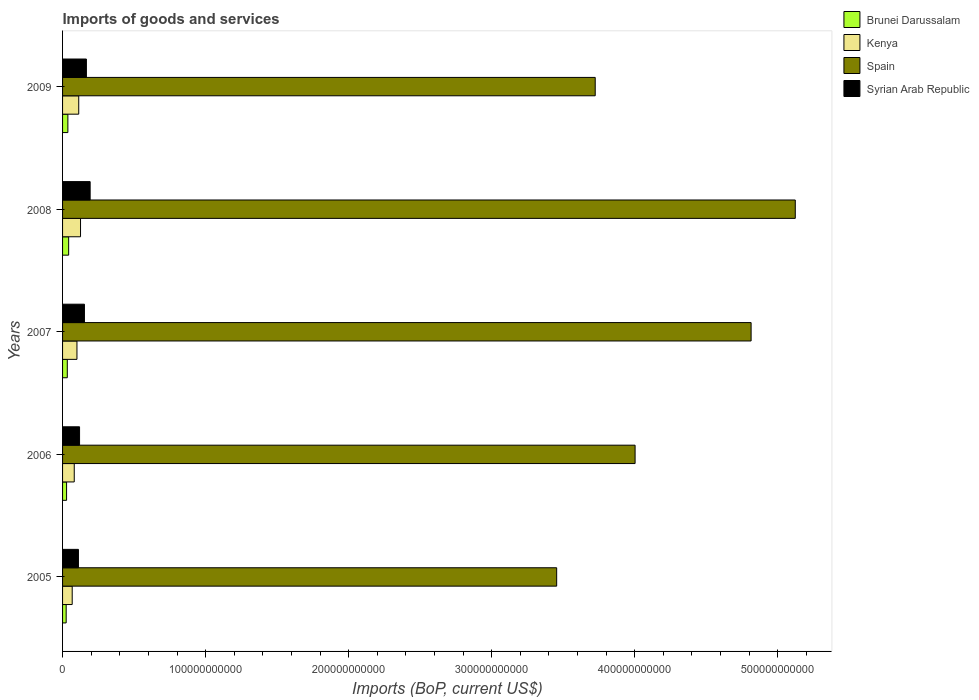How many groups of bars are there?
Provide a succinct answer. 5. Are the number of bars per tick equal to the number of legend labels?
Provide a succinct answer. Yes. How many bars are there on the 3rd tick from the bottom?
Keep it short and to the point. 4. What is the label of the 2nd group of bars from the top?
Make the answer very short. 2008. In how many cases, is the number of bars for a given year not equal to the number of legend labels?
Make the answer very short. 0. What is the amount spent on imports in Spain in 2006?
Offer a terse response. 4.00e+11. Across all years, what is the maximum amount spent on imports in Syrian Arab Republic?
Provide a short and direct response. 1.93e+1. Across all years, what is the minimum amount spent on imports in Syrian Arab Republic?
Make the answer very short. 1.11e+1. In which year was the amount spent on imports in Spain minimum?
Offer a very short reply. 2005. What is the total amount spent on imports in Kenya in the graph?
Provide a short and direct response. 4.88e+1. What is the difference between the amount spent on imports in Kenya in 2007 and that in 2008?
Keep it short and to the point. -2.50e+09. What is the difference between the amount spent on imports in Brunei Darussalam in 2005 and the amount spent on imports in Syrian Arab Republic in 2009?
Your response must be concise. -1.41e+1. What is the average amount spent on imports in Brunei Darussalam per year?
Your answer should be very brief. 3.32e+09. In the year 2005, what is the difference between the amount spent on imports in Brunei Darussalam and amount spent on imports in Spain?
Offer a very short reply. -3.43e+11. In how many years, is the amount spent on imports in Kenya greater than 380000000000 US$?
Offer a very short reply. 0. What is the ratio of the amount spent on imports in Spain in 2005 to that in 2008?
Your response must be concise. 0.67. Is the amount spent on imports in Kenya in 2005 less than that in 2009?
Your answer should be very brief. Yes. Is the difference between the amount spent on imports in Brunei Darussalam in 2007 and 2009 greater than the difference between the amount spent on imports in Spain in 2007 and 2009?
Provide a succinct answer. No. What is the difference between the highest and the second highest amount spent on imports in Brunei Darussalam?
Give a very brief answer. 5.44e+08. What is the difference between the highest and the lowest amount spent on imports in Spain?
Your answer should be very brief. 1.67e+11. In how many years, is the amount spent on imports in Syrian Arab Republic greater than the average amount spent on imports in Syrian Arab Republic taken over all years?
Your answer should be very brief. 3. Is it the case that in every year, the sum of the amount spent on imports in Brunei Darussalam and amount spent on imports in Spain is greater than the sum of amount spent on imports in Syrian Arab Republic and amount spent on imports in Kenya?
Your answer should be compact. No. What does the 3rd bar from the top in 2005 represents?
Keep it short and to the point. Kenya. Is it the case that in every year, the sum of the amount spent on imports in Brunei Darussalam and amount spent on imports in Spain is greater than the amount spent on imports in Syrian Arab Republic?
Give a very brief answer. Yes. How many bars are there?
Offer a terse response. 20. What is the difference between two consecutive major ticks on the X-axis?
Provide a succinct answer. 1.00e+11. Are the values on the major ticks of X-axis written in scientific E-notation?
Offer a very short reply. No. Does the graph contain any zero values?
Your answer should be compact. No. Where does the legend appear in the graph?
Provide a succinct answer. Top right. How are the legend labels stacked?
Make the answer very short. Vertical. What is the title of the graph?
Ensure brevity in your answer.  Imports of goods and services. Does "Qatar" appear as one of the legend labels in the graph?
Keep it short and to the point. No. What is the label or title of the X-axis?
Make the answer very short. Imports (BoP, current US$). What is the Imports (BoP, current US$) of Brunei Darussalam in 2005?
Your answer should be compact. 2.52e+09. What is the Imports (BoP, current US$) of Kenya in 2005?
Give a very brief answer. 6.74e+09. What is the Imports (BoP, current US$) of Spain in 2005?
Your answer should be compact. 3.45e+11. What is the Imports (BoP, current US$) in Syrian Arab Republic in 2005?
Ensure brevity in your answer.  1.11e+1. What is the Imports (BoP, current US$) in Brunei Darussalam in 2006?
Provide a succinct answer. 2.80e+09. What is the Imports (BoP, current US$) of Kenya in 2006?
Give a very brief answer. 8.17e+09. What is the Imports (BoP, current US$) in Spain in 2006?
Make the answer very short. 4.00e+11. What is the Imports (BoP, current US$) in Syrian Arab Republic in 2006?
Your response must be concise. 1.19e+1. What is the Imports (BoP, current US$) of Brunei Darussalam in 2007?
Provide a succinct answer. 3.31e+09. What is the Imports (BoP, current US$) in Kenya in 2007?
Your response must be concise. 1.01e+1. What is the Imports (BoP, current US$) in Spain in 2007?
Ensure brevity in your answer.  4.81e+11. What is the Imports (BoP, current US$) of Syrian Arab Republic in 2007?
Offer a terse response. 1.53e+1. What is the Imports (BoP, current US$) in Brunei Darussalam in 2008?
Provide a succinct answer. 4.26e+09. What is the Imports (BoP, current US$) of Kenya in 2008?
Ensure brevity in your answer.  1.26e+1. What is the Imports (BoP, current US$) of Spain in 2008?
Ensure brevity in your answer.  5.12e+11. What is the Imports (BoP, current US$) in Syrian Arab Republic in 2008?
Ensure brevity in your answer.  1.93e+1. What is the Imports (BoP, current US$) of Brunei Darussalam in 2009?
Your response must be concise. 3.72e+09. What is the Imports (BoP, current US$) of Kenya in 2009?
Offer a very short reply. 1.13e+1. What is the Imports (BoP, current US$) of Spain in 2009?
Your answer should be compact. 3.72e+11. What is the Imports (BoP, current US$) in Syrian Arab Republic in 2009?
Give a very brief answer. 1.67e+1. Across all years, what is the maximum Imports (BoP, current US$) of Brunei Darussalam?
Your answer should be compact. 4.26e+09. Across all years, what is the maximum Imports (BoP, current US$) in Kenya?
Ensure brevity in your answer.  1.26e+1. Across all years, what is the maximum Imports (BoP, current US$) of Spain?
Ensure brevity in your answer.  5.12e+11. Across all years, what is the maximum Imports (BoP, current US$) in Syrian Arab Republic?
Your response must be concise. 1.93e+1. Across all years, what is the minimum Imports (BoP, current US$) in Brunei Darussalam?
Keep it short and to the point. 2.52e+09. Across all years, what is the minimum Imports (BoP, current US$) of Kenya?
Your response must be concise. 6.74e+09. Across all years, what is the minimum Imports (BoP, current US$) in Spain?
Ensure brevity in your answer.  3.45e+11. Across all years, what is the minimum Imports (BoP, current US$) in Syrian Arab Republic?
Offer a terse response. 1.11e+1. What is the total Imports (BoP, current US$) in Brunei Darussalam in the graph?
Provide a short and direct response. 1.66e+1. What is the total Imports (BoP, current US$) in Kenya in the graph?
Give a very brief answer. 4.88e+1. What is the total Imports (BoP, current US$) in Spain in the graph?
Your response must be concise. 2.11e+12. What is the total Imports (BoP, current US$) of Syrian Arab Republic in the graph?
Your answer should be compact. 7.42e+1. What is the difference between the Imports (BoP, current US$) in Brunei Darussalam in 2005 and that in 2006?
Ensure brevity in your answer.  -2.80e+08. What is the difference between the Imports (BoP, current US$) in Kenya in 2005 and that in 2006?
Make the answer very short. -1.43e+09. What is the difference between the Imports (BoP, current US$) in Spain in 2005 and that in 2006?
Provide a succinct answer. -5.48e+1. What is the difference between the Imports (BoP, current US$) in Syrian Arab Republic in 2005 and that in 2006?
Your answer should be compact. -7.78e+08. What is the difference between the Imports (BoP, current US$) in Brunei Darussalam in 2005 and that in 2007?
Your answer should be compact. -7.87e+08. What is the difference between the Imports (BoP, current US$) in Kenya in 2005 and that in 2007?
Keep it short and to the point. -3.32e+09. What is the difference between the Imports (BoP, current US$) of Spain in 2005 and that in 2007?
Your answer should be very brief. -1.36e+11. What is the difference between the Imports (BoP, current US$) of Syrian Arab Republic in 2005 and that in 2007?
Your response must be concise. -4.19e+09. What is the difference between the Imports (BoP, current US$) of Brunei Darussalam in 2005 and that in 2008?
Offer a terse response. -1.74e+09. What is the difference between the Imports (BoP, current US$) in Kenya in 2005 and that in 2008?
Give a very brief answer. -5.82e+09. What is the difference between the Imports (BoP, current US$) in Spain in 2005 and that in 2008?
Your response must be concise. -1.67e+11. What is the difference between the Imports (BoP, current US$) of Syrian Arab Republic in 2005 and that in 2008?
Give a very brief answer. -8.18e+09. What is the difference between the Imports (BoP, current US$) in Brunei Darussalam in 2005 and that in 2009?
Provide a short and direct response. -1.19e+09. What is the difference between the Imports (BoP, current US$) of Kenya in 2005 and that in 2009?
Offer a very short reply. -4.56e+09. What is the difference between the Imports (BoP, current US$) of Spain in 2005 and that in 2009?
Offer a very short reply. -2.69e+1. What is the difference between the Imports (BoP, current US$) in Syrian Arab Republic in 2005 and that in 2009?
Offer a terse response. -5.57e+09. What is the difference between the Imports (BoP, current US$) in Brunei Darussalam in 2006 and that in 2007?
Give a very brief answer. -5.07e+08. What is the difference between the Imports (BoP, current US$) in Kenya in 2006 and that in 2007?
Provide a short and direct response. -1.89e+09. What is the difference between the Imports (BoP, current US$) of Spain in 2006 and that in 2007?
Offer a very short reply. -8.11e+1. What is the difference between the Imports (BoP, current US$) of Syrian Arab Republic in 2006 and that in 2007?
Your answer should be very brief. -3.41e+09. What is the difference between the Imports (BoP, current US$) in Brunei Darussalam in 2006 and that in 2008?
Provide a succinct answer. -1.46e+09. What is the difference between the Imports (BoP, current US$) in Kenya in 2006 and that in 2008?
Your answer should be compact. -4.39e+09. What is the difference between the Imports (BoP, current US$) of Spain in 2006 and that in 2008?
Provide a succinct answer. -1.12e+11. What is the difference between the Imports (BoP, current US$) of Syrian Arab Republic in 2006 and that in 2008?
Ensure brevity in your answer.  -7.40e+09. What is the difference between the Imports (BoP, current US$) in Brunei Darussalam in 2006 and that in 2009?
Your answer should be compact. -9.15e+08. What is the difference between the Imports (BoP, current US$) in Kenya in 2006 and that in 2009?
Your answer should be compact. -3.13e+09. What is the difference between the Imports (BoP, current US$) in Spain in 2006 and that in 2009?
Provide a succinct answer. 2.79e+1. What is the difference between the Imports (BoP, current US$) in Syrian Arab Republic in 2006 and that in 2009?
Offer a very short reply. -4.79e+09. What is the difference between the Imports (BoP, current US$) of Brunei Darussalam in 2007 and that in 2008?
Provide a short and direct response. -9.52e+08. What is the difference between the Imports (BoP, current US$) of Kenya in 2007 and that in 2008?
Ensure brevity in your answer.  -2.50e+09. What is the difference between the Imports (BoP, current US$) of Spain in 2007 and that in 2008?
Ensure brevity in your answer.  -3.09e+1. What is the difference between the Imports (BoP, current US$) in Syrian Arab Republic in 2007 and that in 2008?
Your answer should be compact. -3.99e+09. What is the difference between the Imports (BoP, current US$) in Brunei Darussalam in 2007 and that in 2009?
Offer a terse response. -4.08e+08. What is the difference between the Imports (BoP, current US$) of Kenya in 2007 and that in 2009?
Keep it short and to the point. -1.24e+09. What is the difference between the Imports (BoP, current US$) of Spain in 2007 and that in 2009?
Provide a succinct answer. 1.09e+11. What is the difference between the Imports (BoP, current US$) of Syrian Arab Republic in 2007 and that in 2009?
Make the answer very short. -1.38e+09. What is the difference between the Imports (BoP, current US$) of Brunei Darussalam in 2008 and that in 2009?
Make the answer very short. 5.44e+08. What is the difference between the Imports (BoP, current US$) of Kenya in 2008 and that in 2009?
Offer a very short reply. 1.26e+09. What is the difference between the Imports (BoP, current US$) of Spain in 2008 and that in 2009?
Your answer should be compact. 1.40e+11. What is the difference between the Imports (BoP, current US$) of Syrian Arab Republic in 2008 and that in 2009?
Provide a succinct answer. 2.61e+09. What is the difference between the Imports (BoP, current US$) of Brunei Darussalam in 2005 and the Imports (BoP, current US$) of Kenya in 2006?
Your response must be concise. -5.65e+09. What is the difference between the Imports (BoP, current US$) of Brunei Darussalam in 2005 and the Imports (BoP, current US$) of Spain in 2006?
Keep it short and to the point. -3.98e+11. What is the difference between the Imports (BoP, current US$) of Brunei Darussalam in 2005 and the Imports (BoP, current US$) of Syrian Arab Republic in 2006?
Provide a short and direct response. -9.36e+09. What is the difference between the Imports (BoP, current US$) in Kenya in 2005 and the Imports (BoP, current US$) in Spain in 2006?
Make the answer very short. -3.94e+11. What is the difference between the Imports (BoP, current US$) in Kenya in 2005 and the Imports (BoP, current US$) in Syrian Arab Republic in 2006?
Offer a very short reply. -5.14e+09. What is the difference between the Imports (BoP, current US$) in Spain in 2005 and the Imports (BoP, current US$) in Syrian Arab Republic in 2006?
Ensure brevity in your answer.  3.34e+11. What is the difference between the Imports (BoP, current US$) of Brunei Darussalam in 2005 and the Imports (BoP, current US$) of Kenya in 2007?
Your answer should be compact. -7.54e+09. What is the difference between the Imports (BoP, current US$) of Brunei Darussalam in 2005 and the Imports (BoP, current US$) of Spain in 2007?
Make the answer very short. -4.79e+11. What is the difference between the Imports (BoP, current US$) of Brunei Darussalam in 2005 and the Imports (BoP, current US$) of Syrian Arab Republic in 2007?
Provide a succinct answer. -1.28e+1. What is the difference between the Imports (BoP, current US$) in Kenya in 2005 and the Imports (BoP, current US$) in Spain in 2007?
Ensure brevity in your answer.  -4.75e+11. What is the difference between the Imports (BoP, current US$) in Kenya in 2005 and the Imports (BoP, current US$) in Syrian Arab Republic in 2007?
Your answer should be very brief. -8.55e+09. What is the difference between the Imports (BoP, current US$) in Spain in 2005 and the Imports (BoP, current US$) in Syrian Arab Republic in 2007?
Offer a very short reply. 3.30e+11. What is the difference between the Imports (BoP, current US$) in Brunei Darussalam in 2005 and the Imports (BoP, current US$) in Kenya in 2008?
Provide a short and direct response. -1.00e+1. What is the difference between the Imports (BoP, current US$) of Brunei Darussalam in 2005 and the Imports (BoP, current US$) of Spain in 2008?
Ensure brevity in your answer.  -5.10e+11. What is the difference between the Imports (BoP, current US$) in Brunei Darussalam in 2005 and the Imports (BoP, current US$) in Syrian Arab Republic in 2008?
Make the answer very short. -1.68e+1. What is the difference between the Imports (BoP, current US$) in Kenya in 2005 and the Imports (BoP, current US$) in Spain in 2008?
Your answer should be compact. -5.06e+11. What is the difference between the Imports (BoP, current US$) of Kenya in 2005 and the Imports (BoP, current US$) of Syrian Arab Republic in 2008?
Provide a succinct answer. -1.25e+1. What is the difference between the Imports (BoP, current US$) in Spain in 2005 and the Imports (BoP, current US$) in Syrian Arab Republic in 2008?
Provide a succinct answer. 3.26e+11. What is the difference between the Imports (BoP, current US$) in Brunei Darussalam in 2005 and the Imports (BoP, current US$) in Kenya in 2009?
Your answer should be very brief. -8.78e+09. What is the difference between the Imports (BoP, current US$) in Brunei Darussalam in 2005 and the Imports (BoP, current US$) in Spain in 2009?
Your response must be concise. -3.70e+11. What is the difference between the Imports (BoP, current US$) of Brunei Darussalam in 2005 and the Imports (BoP, current US$) of Syrian Arab Republic in 2009?
Your answer should be compact. -1.41e+1. What is the difference between the Imports (BoP, current US$) in Kenya in 2005 and the Imports (BoP, current US$) in Spain in 2009?
Keep it short and to the point. -3.66e+11. What is the difference between the Imports (BoP, current US$) of Kenya in 2005 and the Imports (BoP, current US$) of Syrian Arab Republic in 2009?
Make the answer very short. -9.93e+09. What is the difference between the Imports (BoP, current US$) in Spain in 2005 and the Imports (BoP, current US$) in Syrian Arab Republic in 2009?
Keep it short and to the point. 3.29e+11. What is the difference between the Imports (BoP, current US$) in Brunei Darussalam in 2006 and the Imports (BoP, current US$) in Kenya in 2007?
Offer a very short reply. -7.26e+09. What is the difference between the Imports (BoP, current US$) in Brunei Darussalam in 2006 and the Imports (BoP, current US$) in Spain in 2007?
Provide a short and direct response. -4.79e+11. What is the difference between the Imports (BoP, current US$) of Brunei Darussalam in 2006 and the Imports (BoP, current US$) of Syrian Arab Republic in 2007?
Give a very brief answer. -1.25e+1. What is the difference between the Imports (BoP, current US$) of Kenya in 2006 and the Imports (BoP, current US$) of Spain in 2007?
Provide a short and direct response. -4.73e+11. What is the difference between the Imports (BoP, current US$) of Kenya in 2006 and the Imports (BoP, current US$) of Syrian Arab Republic in 2007?
Offer a terse response. -7.12e+09. What is the difference between the Imports (BoP, current US$) in Spain in 2006 and the Imports (BoP, current US$) in Syrian Arab Republic in 2007?
Offer a terse response. 3.85e+11. What is the difference between the Imports (BoP, current US$) in Brunei Darussalam in 2006 and the Imports (BoP, current US$) in Kenya in 2008?
Ensure brevity in your answer.  -9.76e+09. What is the difference between the Imports (BoP, current US$) of Brunei Darussalam in 2006 and the Imports (BoP, current US$) of Spain in 2008?
Your answer should be very brief. -5.09e+11. What is the difference between the Imports (BoP, current US$) in Brunei Darussalam in 2006 and the Imports (BoP, current US$) in Syrian Arab Republic in 2008?
Keep it short and to the point. -1.65e+1. What is the difference between the Imports (BoP, current US$) in Kenya in 2006 and the Imports (BoP, current US$) in Spain in 2008?
Offer a very short reply. -5.04e+11. What is the difference between the Imports (BoP, current US$) in Kenya in 2006 and the Imports (BoP, current US$) in Syrian Arab Republic in 2008?
Offer a terse response. -1.11e+1. What is the difference between the Imports (BoP, current US$) in Spain in 2006 and the Imports (BoP, current US$) in Syrian Arab Republic in 2008?
Make the answer very short. 3.81e+11. What is the difference between the Imports (BoP, current US$) in Brunei Darussalam in 2006 and the Imports (BoP, current US$) in Kenya in 2009?
Give a very brief answer. -8.50e+09. What is the difference between the Imports (BoP, current US$) of Brunei Darussalam in 2006 and the Imports (BoP, current US$) of Spain in 2009?
Your response must be concise. -3.70e+11. What is the difference between the Imports (BoP, current US$) of Brunei Darussalam in 2006 and the Imports (BoP, current US$) of Syrian Arab Republic in 2009?
Offer a very short reply. -1.39e+1. What is the difference between the Imports (BoP, current US$) of Kenya in 2006 and the Imports (BoP, current US$) of Spain in 2009?
Give a very brief answer. -3.64e+11. What is the difference between the Imports (BoP, current US$) of Kenya in 2006 and the Imports (BoP, current US$) of Syrian Arab Republic in 2009?
Keep it short and to the point. -8.50e+09. What is the difference between the Imports (BoP, current US$) in Spain in 2006 and the Imports (BoP, current US$) in Syrian Arab Republic in 2009?
Ensure brevity in your answer.  3.84e+11. What is the difference between the Imports (BoP, current US$) of Brunei Darussalam in 2007 and the Imports (BoP, current US$) of Kenya in 2008?
Offer a terse response. -9.25e+09. What is the difference between the Imports (BoP, current US$) in Brunei Darussalam in 2007 and the Imports (BoP, current US$) in Spain in 2008?
Provide a short and direct response. -5.09e+11. What is the difference between the Imports (BoP, current US$) in Brunei Darussalam in 2007 and the Imports (BoP, current US$) in Syrian Arab Republic in 2008?
Ensure brevity in your answer.  -1.60e+1. What is the difference between the Imports (BoP, current US$) in Kenya in 2007 and the Imports (BoP, current US$) in Spain in 2008?
Offer a very short reply. -5.02e+11. What is the difference between the Imports (BoP, current US$) in Kenya in 2007 and the Imports (BoP, current US$) in Syrian Arab Republic in 2008?
Offer a terse response. -9.22e+09. What is the difference between the Imports (BoP, current US$) in Spain in 2007 and the Imports (BoP, current US$) in Syrian Arab Republic in 2008?
Provide a succinct answer. 4.62e+11. What is the difference between the Imports (BoP, current US$) of Brunei Darussalam in 2007 and the Imports (BoP, current US$) of Kenya in 2009?
Keep it short and to the point. -7.99e+09. What is the difference between the Imports (BoP, current US$) in Brunei Darussalam in 2007 and the Imports (BoP, current US$) in Spain in 2009?
Provide a succinct answer. -3.69e+11. What is the difference between the Imports (BoP, current US$) in Brunei Darussalam in 2007 and the Imports (BoP, current US$) in Syrian Arab Republic in 2009?
Make the answer very short. -1.34e+1. What is the difference between the Imports (BoP, current US$) of Kenya in 2007 and the Imports (BoP, current US$) of Spain in 2009?
Offer a terse response. -3.62e+11. What is the difference between the Imports (BoP, current US$) in Kenya in 2007 and the Imports (BoP, current US$) in Syrian Arab Republic in 2009?
Ensure brevity in your answer.  -6.61e+09. What is the difference between the Imports (BoP, current US$) in Spain in 2007 and the Imports (BoP, current US$) in Syrian Arab Republic in 2009?
Make the answer very short. 4.65e+11. What is the difference between the Imports (BoP, current US$) in Brunei Darussalam in 2008 and the Imports (BoP, current US$) in Kenya in 2009?
Offer a terse response. -7.04e+09. What is the difference between the Imports (BoP, current US$) of Brunei Darussalam in 2008 and the Imports (BoP, current US$) of Spain in 2009?
Ensure brevity in your answer.  -3.68e+11. What is the difference between the Imports (BoP, current US$) in Brunei Darussalam in 2008 and the Imports (BoP, current US$) in Syrian Arab Republic in 2009?
Offer a terse response. -1.24e+1. What is the difference between the Imports (BoP, current US$) of Kenya in 2008 and the Imports (BoP, current US$) of Spain in 2009?
Offer a very short reply. -3.60e+11. What is the difference between the Imports (BoP, current US$) of Kenya in 2008 and the Imports (BoP, current US$) of Syrian Arab Republic in 2009?
Offer a very short reply. -4.11e+09. What is the difference between the Imports (BoP, current US$) of Spain in 2008 and the Imports (BoP, current US$) of Syrian Arab Republic in 2009?
Your response must be concise. 4.96e+11. What is the average Imports (BoP, current US$) of Brunei Darussalam per year?
Ensure brevity in your answer.  3.32e+09. What is the average Imports (BoP, current US$) of Kenya per year?
Provide a succinct answer. 9.77e+09. What is the average Imports (BoP, current US$) of Spain per year?
Your answer should be very brief. 4.22e+11. What is the average Imports (BoP, current US$) of Syrian Arab Republic per year?
Your response must be concise. 1.48e+1. In the year 2005, what is the difference between the Imports (BoP, current US$) in Brunei Darussalam and Imports (BoP, current US$) in Kenya?
Provide a succinct answer. -4.22e+09. In the year 2005, what is the difference between the Imports (BoP, current US$) of Brunei Darussalam and Imports (BoP, current US$) of Spain?
Your answer should be compact. -3.43e+11. In the year 2005, what is the difference between the Imports (BoP, current US$) in Brunei Darussalam and Imports (BoP, current US$) in Syrian Arab Republic?
Keep it short and to the point. -8.58e+09. In the year 2005, what is the difference between the Imports (BoP, current US$) in Kenya and Imports (BoP, current US$) in Spain?
Provide a short and direct response. -3.39e+11. In the year 2005, what is the difference between the Imports (BoP, current US$) in Kenya and Imports (BoP, current US$) in Syrian Arab Republic?
Offer a very short reply. -4.36e+09. In the year 2005, what is the difference between the Imports (BoP, current US$) of Spain and Imports (BoP, current US$) of Syrian Arab Republic?
Your answer should be very brief. 3.34e+11. In the year 2006, what is the difference between the Imports (BoP, current US$) in Brunei Darussalam and Imports (BoP, current US$) in Kenya?
Make the answer very short. -5.37e+09. In the year 2006, what is the difference between the Imports (BoP, current US$) of Brunei Darussalam and Imports (BoP, current US$) of Spain?
Your answer should be compact. -3.97e+11. In the year 2006, what is the difference between the Imports (BoP, current US$) of Brunei Darussalam and Imports (BoP, current US$) of Syrian Arab Republic?
Give a very brief answer. -9.08e+09. In the year 2006, what is the difference between the Imports (BoP, current US$) in Kenya and Imports (BoP, current US$) in Spain?
Offer a terse response. -3.92e+11. In the year 2006, what is the difference between the Imports (BoP, current US$) of Kenya and Imports (BoP, current US$) of Syrian Arab Republic?
Offer a terse response. -3.71e+09. In the year 2006, what is the difference between the Imports (BoP, current US$) of Spain and Imports (BoP, current US$) of Syrian Arab Republic?
Your answer should be compact. 3.88e+11. In the year 2007, what is the difference between the Imports (BoP, current US$) of Brunei Darussalam and Imports (BoP, current US$) of Kenya?
Your answer should be very brief. -6.75e+09. In the year 2007, what is the difference between the Imports (BoP, current US$) in Brunei Darussalam and Imports (BoP, current US$) in Spain?
Provide a short and direct response. -4.78e+11. In the year 2007, what is the difference between the Imports (BoP, current US$) of Brunei Darussalam and Imports (BoP, current US$) of Syrian Arab Republic?
Offer a very short reply. -1.20e+1. In the year 2007, what is the difference between the Imports (BoP, current US$) in Kenya and Imports (BoP, current US$) in Spain?
Your answer should be very brief. -4.71e+11. In the year 2007, what is the difference between the Imports (BoP, current US$) in Kenya and Imports (BoP, current US$) in Syrian Arab Republic?
Your answer should be very brief. -5.23e+09. In the year 2007, what is the difference between the Imports (BoP, current US$) of Spain and Imports (BoP, current US$) of Syrian Arab Republic?
Provide a succinct answer. 4.66e+11. In the year 2008, what is the difference between the Imports (BoP, current US$) of Brunei Darussalam and Imports (BoP, current US$) of Kenya?
Provide a short and direct response. -8.30e+09. In the year 2008, what is the difference between the Imports (BoP, current US$) of Brunei Darussalam and Imports (BoP, current US$) of Spain?
Your response must be concise. -5.08e+11. In the year 2008, what is the difference between the Imports (BoP, current US$) in Brunei Darussalam and Imports (BoP, current US$) in Syrian Arab Republic?
Make the answer very short. -1.50e+1. In the year 2008, what is the difference between the Imports (BoP, current US$) in Kenya and Imports (BoP, current US$) in Spain?
Offer a very short reply. -5.00e+11. In the year 2008, what is the difference between the Imports (BoP, current US$) of Kenya and Imports (BoP, current US$) of Syrian Arab Republic?
Your answer should be compact. -6.72e+09. In the year 2008, what is the difference between the Imports (BoP, current US$) of Spain and Imports (BoP, current US$) of Syrian Arab Republic?
Provide a succinct answer. 4.93e+11. In the year 2009, what is the difference between the Imports (BoP, current US$) of Brunei Darussalam and Imports (BoP, current US$) of Kenya?
Provide a succinct answer. -7.59e+09. In the year 2009, what is the difference between the Imports (BoP, current US$) of Brunei Darussalam and Imports (BoP, current US$) of Spain?
Your answer should be very brief. -3.69e+11. In the year 2009, what is the difference between the Imports (BoP, current US$) of Brunei Darussalam and Imports (BoP, current US$) of Syrian Arab Republic?
Offer a very short reply. -1.30e+1. In the year 2009, what is the difference between the Imports (BoP, current US$) in Kenya and Imports (BoP, current US$) in Spain?
Your response must be concise. -3.61e+11. In the year 2009, what is the difference between the Imports (BoP, current US$) in Kenya and Imports (BoP, current US$) in Syrian Arab Republic?
Make the answer very short. -5.37e+09. In the year 2009, what is the difference between the Imports (BoP, current US$) in Spain and Imports (BoP, current US$) in Syrian Arab Republic?
Offer a terse response. 3.56e+11. What is the ratio of the Imports (BoP, current US$) in Brunei Darussalam in 2005 to that in 2006?
Ensure brevity in your answer.  0.9. What is the ratio of the Imports (BoP, current US$) of Kenya in 2005 to that in 2006?
Your response must be concise. 0.82. What is the ratio of the Imports (BoP, current US$) in Spain in 2005 to that in 2006?
Make the answer very short. 0.86. What is the ratio of the Imports (BoP, current US$) in Syrian Arab Republic in 2005 to that in 2006?
Provide a short and direct response. 0.93. What is the ratio of the Imports (BoP, current US$) in Brunei Darussalam in 2005 to that in 2007?
Your answer should be compact. 0.76. What is the ratio of the Imports (BoP, current US$) in Kenya in 2005 to that in 2007?
Offer a very short reply. 0.67. What is the ratio of the Imports (BoP, current US$) in Spain in 2005 to that in 2007?
Keep it short and to the point. 0.72. What is the ratio of the Imports (BoP, current US$) of Syrian Arab Republic in 2005 to that in 2007?
Give a very brief answer. 0.73. What is the ratio of the Imports (BoP, current US$) in Brunei Darussalam in 2005 to that in 2008?
Keep it short and to the point. 0.59. What is the ratio of the Imports (BoP, current US$) of Kenya in 2005 to that in 2008?
Keep it short and to the point. 0.54. What is the ratio of the Imports (BoP, current US$) of Spain in 2005 to that in 2008?
Give a very brief answer. 0.67. What is the ratio of the Imports (BoP, current US$) of Syrian Arab Republic in 2005 to that in 2008?
Your answer should be very brief. 0.58. What is the ratio of the Imports (BoP, current US$) in Brunei Darussalam in 2005 to that in 2009?
Your answer should be compact. 0.68. What is the ratio of the Imports (BoP, current US$) of Kenya in 2005 to that in 2009?
Keep it short and to the point. 0.6. What is the ratio of the Imports (BoP, current US$) of Spain in 2005 to that in 2009?
Keep it short and to the point. 0.93. What is the ratio of the Imports (BoP, current US$) of Syrian Arab Republic in 2005 to that in 2009?
Provide a succinct answer. 0.67. What is the ratio of the Imports (BoP, current US$) in Brunei Darussalam in 2006 to that in 2007?
Provide a succinct answer. 0.85. What is the ratio of the Imports (BoP, current US$) in Kenya in 2006 to that in 2007?
Offer a very short reply. 0.81. What is the ratio of the Imports (BoP, current US$) in Spain in 2006 to that in 2007?
Give a very brief answer. 0.83. What is the ratio of the Imports (BoP, current US$) in Syrian Arab Republic in 2006 to that in 2007?
Offer a terse response. 0.78. What is the ratio of the Imports (BoP, current US$) of Brunei Darussalam in 2006 to that in 2008?
Keep it short and to the point. 0.66. What is the ratio of the Imports (BoP, current US$) in Kenya in 2006 to that in 2008?
Your answer should be compact. 0.65. What is the ratio of the Imports (BoP, current US$) in Spain in 2006 to that in 2008?
Offer a very short reply. 0.78. What is the ratio of the Imports (BoP, current US$) in Syrian Arab Republic in 2006 to that in 2008?
Provide a short and direct response. 0.62. What is the ratio of the Imports (BoP, current US$) of Brunei Darussalam in 2006 to that in 2009?
Your answer should be compact. 0.75. What is the ratio of the Imports (BoP, current US$) of Kenya in 2006 to that in 2009?
Offer a terse response. 0.72. What is the ratio of the Imports (BoP, current US$) in Spain in 2006 to that in 2009?
Your answer should be very brief. 1.07. What is the ratio of the Imports (BoP, current US$) in Syrian Arab Republic in 2006 to that in 2009?
Your response must be concise. 0.71. What is the ratio of the Imports (BoP, current US$) in Brunei Darussalam in 2007 to that in 2008?
Your response must be concise. 0.78. What is the ratio of the Imports (BoP, current US$) of Kenya in 2007 to that in 2008?
Offer a very short reply. 0.8. What is the ratio of the Imports (BoP, current US$) in Spain in 2007 to that in 2008?
Offer a very short reply. 0.94. What is the ratio of the Imports (BoP, current US$) of Syrian Arab Republic in 2007 to that in 2008?
Provide a succinct answer. 0.79. What is the ratio of the Imports (BoP, current US$) of Brunei Darussalam in 2007 to that in 2009?
Your response must be concise. 0.89. What is the ratio of the Imports (BoP, current US$) in Kenya in 2007 to that in 2009?
Offer a terse response. 0.89. What is the ratio of the Imports (BoP, current US$) of Spain in 2007 to that in 2009?
Offer a very short reply. 1.29. What is the ratio of the Imports (BoP, current US$) of Syrian Arab Republic in 2007 to that in 2009?
Offer a very short reply. 0.92. What is the ratio of the Imports (BoP, current US$) in Brunei Darussalam in 2008 to that in 2009?
Provide a short and direct response. 1.15. What is the ratio of the Imports (BoP, current US$) of Kenya in 2008 to that in 2009?
Your response must be concise. 1.11. What is the ratio of the Imports (BoP, current US$) of Spain in 2008 to that in 2009?
Your answer should be compact. 1.38. What is the ratio of the Imports (BoP, current US$) of Syrian Arab Republic in 2008 to that in 2009?
Offer a terse response. 1.16. What is the difference between the highest and the second highest Imports (BoP, current US$) in Brunei Darussalam?
Provide a succinct answer. 5.44e+08. What is the difference between the highest and the second highest Imports (BoP, current US$) of Kenya?
Offer a terse response. 1.26e+09. What is the difference between the highest and the second highest Imports (BoP, current US$) in Spain?
Make the answer very short. 3.09e+1. What is the difference between the highest and the second highest Imports (BoP, current US$) of Syrian Arab Republic?
Your answer should be very brief. 2.61e+09. What is the difference between the highest and the lowest Imports (BoP, current US$) of Brunei Darussalam?
Your response must be concise. 1.74e+09. What is the difference between the highest and the lowest Imports (BoP, current US$) in Kenya?
Your answer should be compact. 5.82e+09. What is the difference between the highest and the lowest Imports (BoP, current US$) in Spain?
Your answer should be compact. 1.67e+11. What is the difference between the highest and the lowest Imports (BoP, current US$) of Syrian Arab Republic?
Make the answer very short. 8.18e+09. 